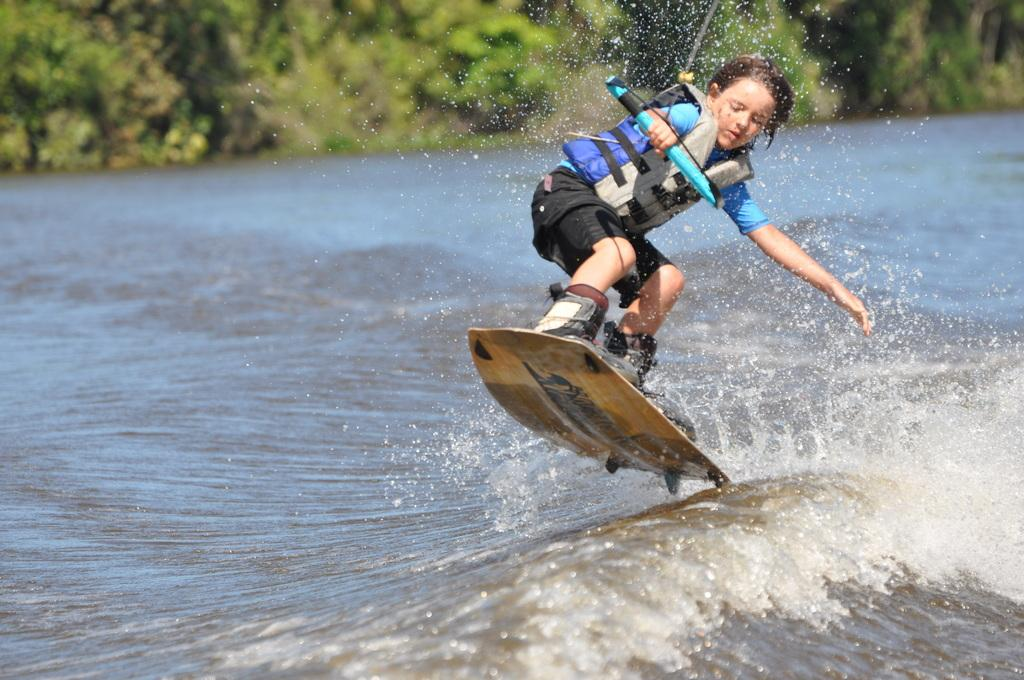What is the main subject of the image? There is a child in the image. What is the child holding in the image? The child is holding an object. What is the child standing on in the image? The child is standing on a surfing board. Where is the surfing board located in the image? The surfing board is above the river. What can be seen in the background of the image? There are trees in the background of the image. What type of club can be seen in the image? There is no club present in the image. Is there a street visible in the image? No, there is no street visible in the image; it features a child standing on a surfing board above a river. Can you see a truck in the image? No, there is no truck present in the image. 